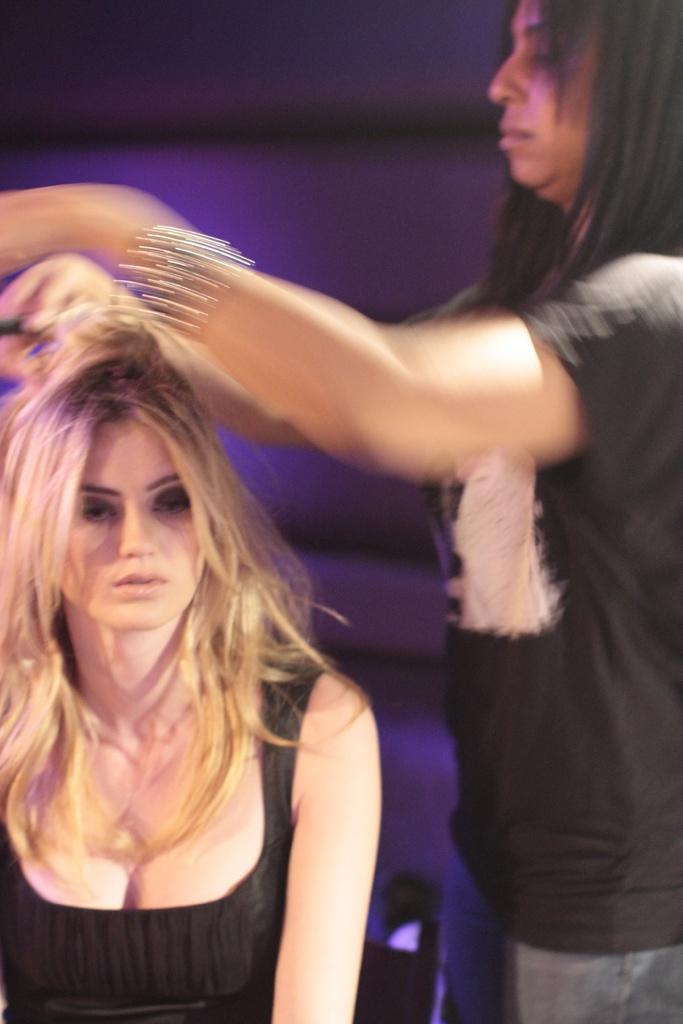How many people are in the image? There are two women in the image. Can you describe the background of the image? The background of the image is blurry. What type of apple is being twisted by one of the women in the image? There is no apple or twisting action present in the image. 